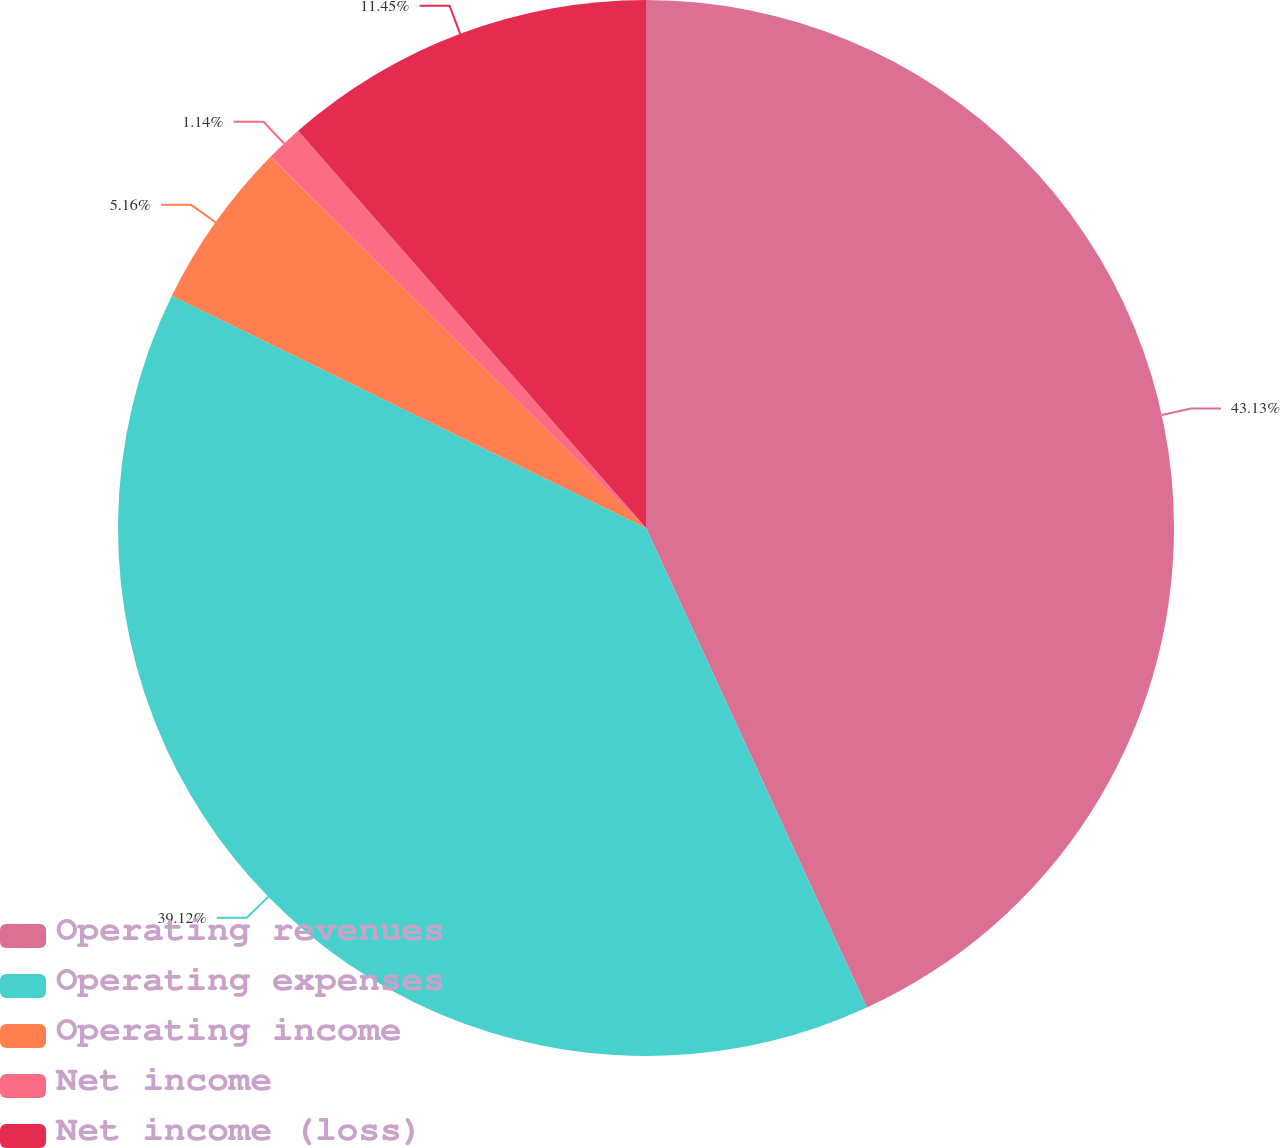<chart> <loc_0><loc_0><loc_500><loc_500><pie_chart><fcel>Operating revenues<fcel>Operating expenses<fcel>Operating income<fcel>Net income<fcel>Net income (loss)<nl><fcel>43.13%<fcel>39.12%<fcel>5.16%<fcel>1.14%<fcel>11.45%<nl></chart> 